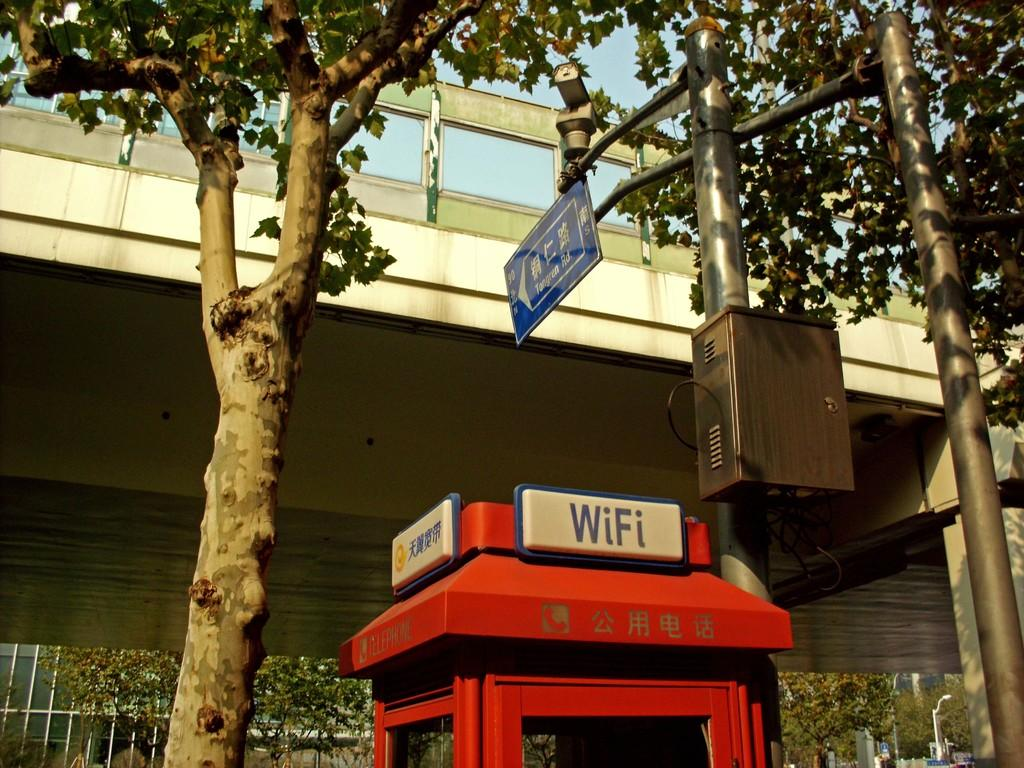<image>
Offer a succinct explanation of the picture presented. The sign on top of the red box advertises WiFi. 